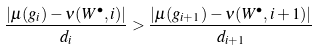Convert formula to latex. <formula><loc_0><loc_0><loc_500><loc_500>\frac { | \mu ( g _ { i } ) - \nu ( W ^ { \bullet } , i ) | } { d _ { i } } > \frac { | \mu ( g _ { i + 1 } ) - \nu ( W ^ { \bullet } , i + 1 ) | } { d _ { i + 1 } }</formula> 